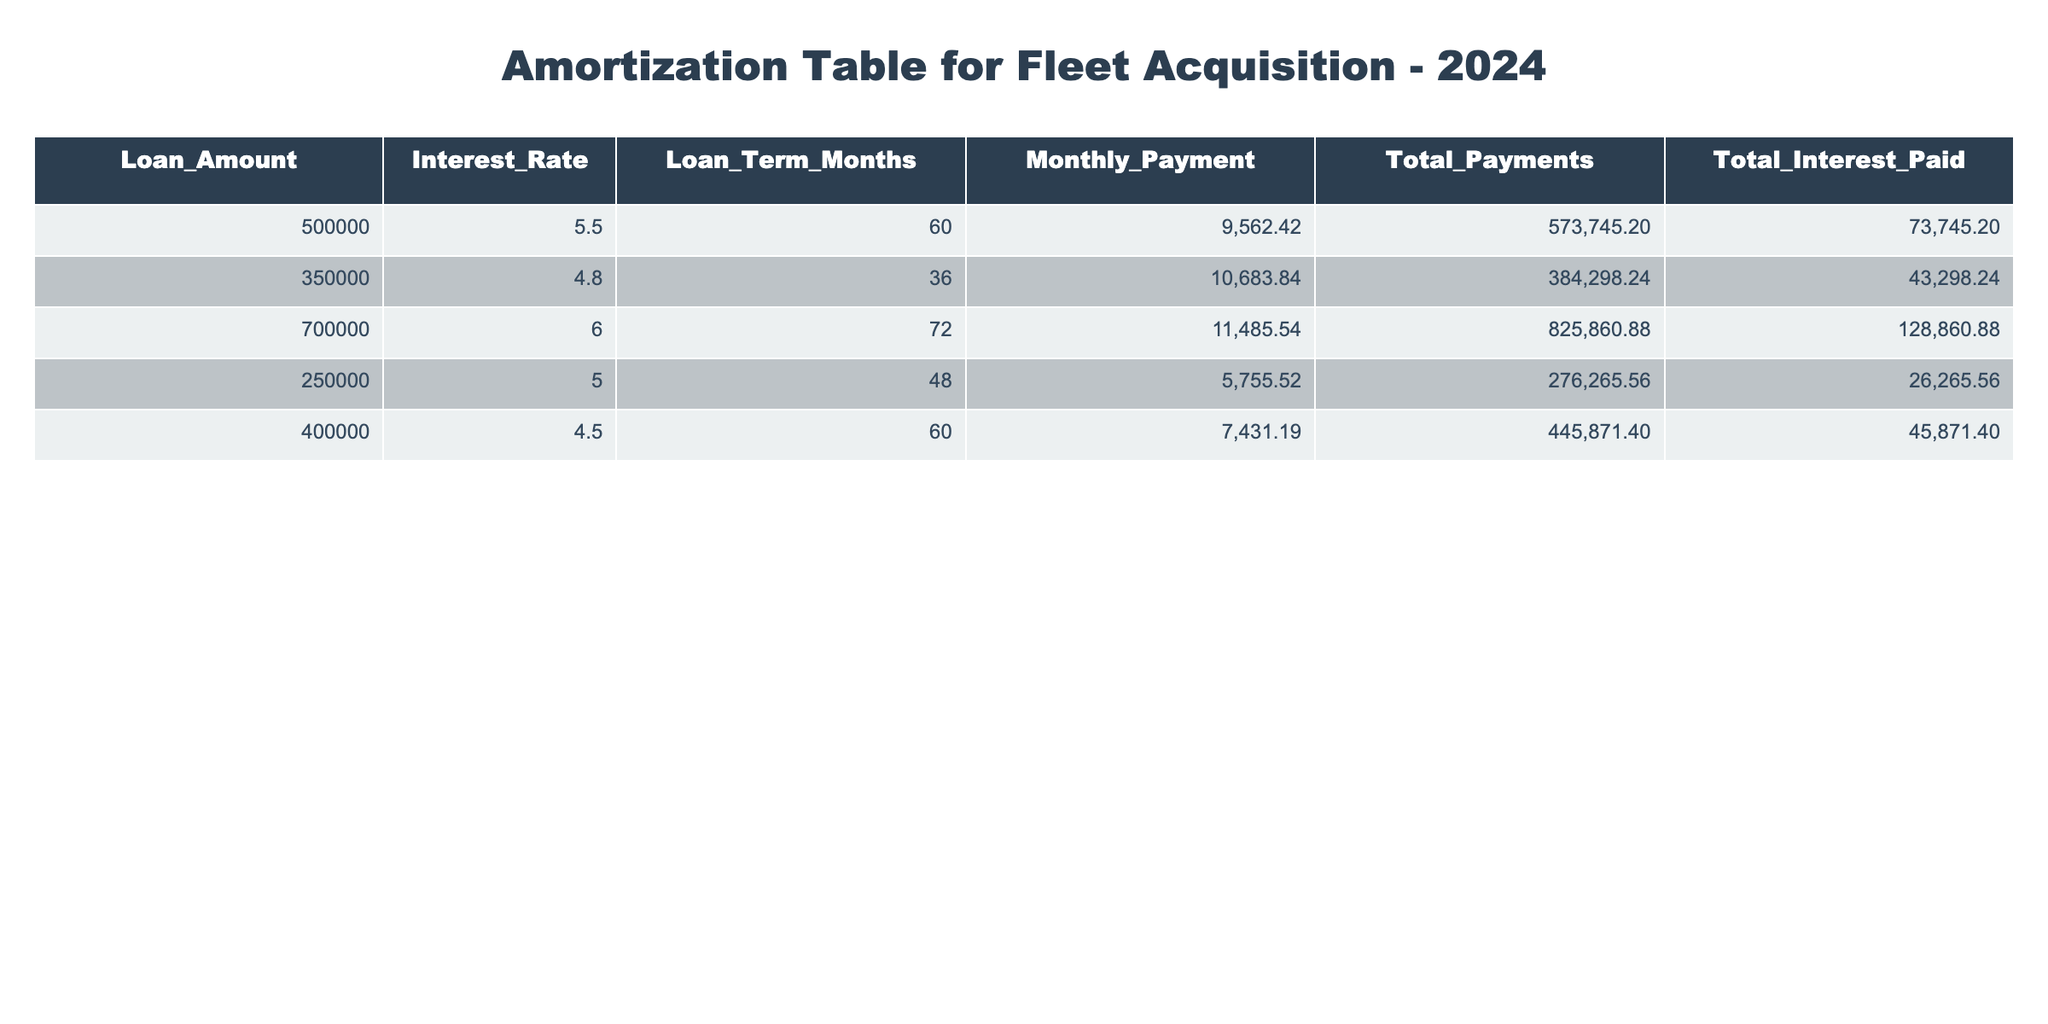What is the monthly payment for the loan of 500,000? The monthly payment for the loan of 500,000 is directly taken from the table under the corresponding column. The value listed is 9562.42.
Answer: 9562.42 What is the total interest paid for the loan of 700,000? The total interest paid for the loan of 700,000 is found in the table under the total interest paid column. The corresponding value is 128860.88.
Answer: 128860.88 Is the interest rate for the loan of 350,000 higher than 5 percent? Looking at the table, the interest rate for the loan of 350,000 is 4.8, which is lower than 5 percent.
Answer: No What is the sum of total payments for loans with terms of 60 months? The loans with terms of 60 months are for amounts of 500,000 and 400,000. Their total payments are 573745.20 and 445871.40, respectively. Summing these gives: 573745.20 + 445871.40 = 1014616.60.
Answer: 1014616.60 Which loan has the lowest total interest paid and what is that amount? The loans and their total interest paid are compared: 73745.20 (500,000), 43298.24 (350,000), 128860.88 (700,000), 26265.56 (250,000), 45871.40 (400,000). The lowest total interest is 26265.56 for the loan of 250,000.
Answer: 26265.56 If the total payments for the loan of 400,000 were reduced by 10,000, what would the new total payments be? The original total payments for the loan of 400,000 are 445871.40. Reducing this by 10,000 gives: 445871.40 - 10000 = 435871.40.
Answer: 435871.40 What is the average monthly payment for all the loans listed? The monthly payments for each loan are 9562.42, 10683.84, 11485.54, 5755.52, and 7431.19. To find the average, the sum (9562.42 + 10683.84 + 11485.54 + 5755.52 + 7431.19) = 49318.51, divided by the number of loans (5) gives: 49318.51 / 5 = 9863.70.
Answer: 9863.70 Is it true that all loans have an interest rate below 6 percent? The interest rates in the table are 5.5, 4.8, 6.0, 5.0, and 4.5. Thus, the loan for 700,000 has an interest rate of 6.0, which is not below 6 percent.
Answer: No 